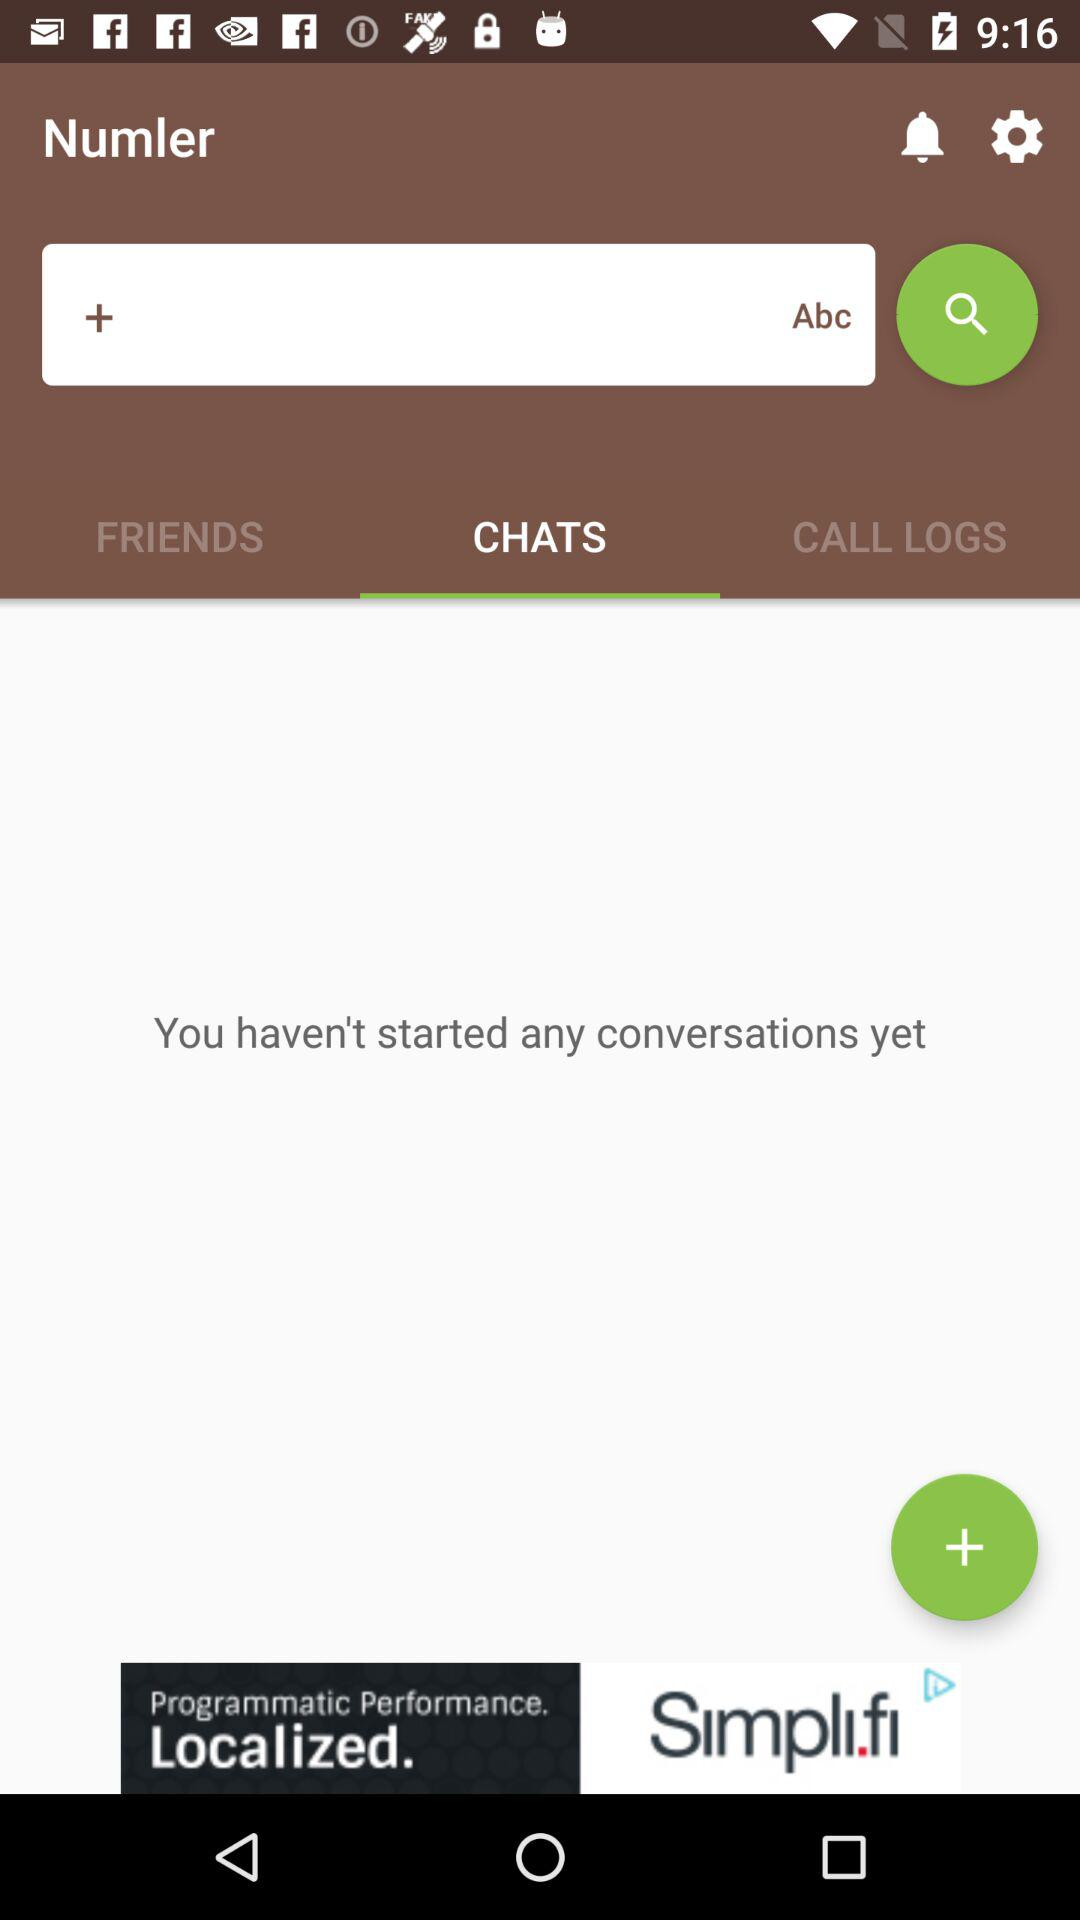Which tab has been selected? The tab "CHATS" has been selected. 